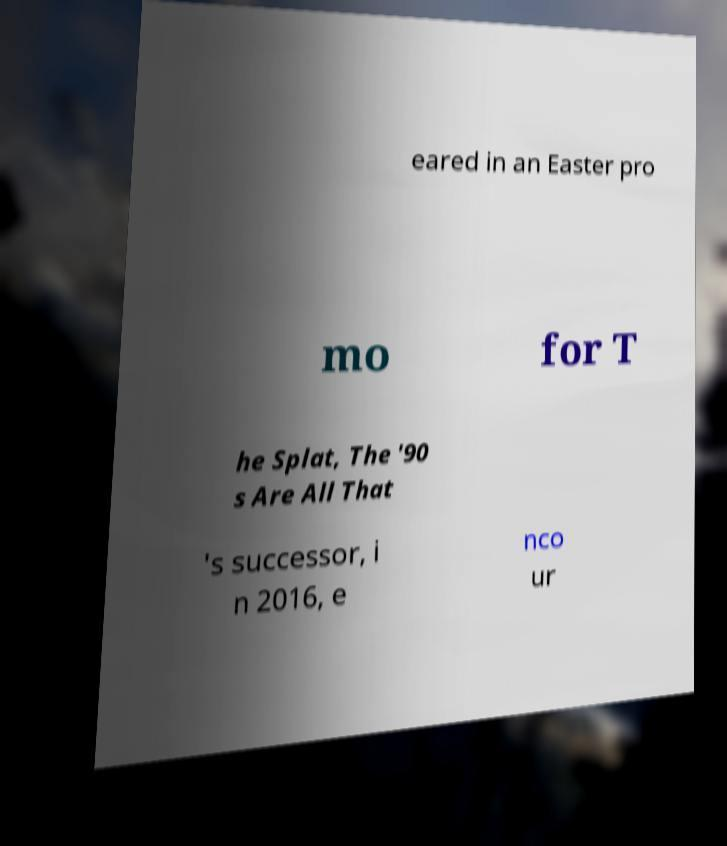Can you read and provide the text displayed in the image?This photo seems to have some interesting text. Can you extract and type it out for me? eared in an Easter pro mo for T he Splat, The '90 s Are All That 's successor, i n 2016, e nco ur 